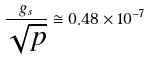Convert formula to latex. <formula><loc_0><loc_0><loc_500><loc_500>\frac { g _ { s } } { \sqrt { p } } \cong 0 . 4 8 \times 1 0 ^ { - 7 }</formula> 